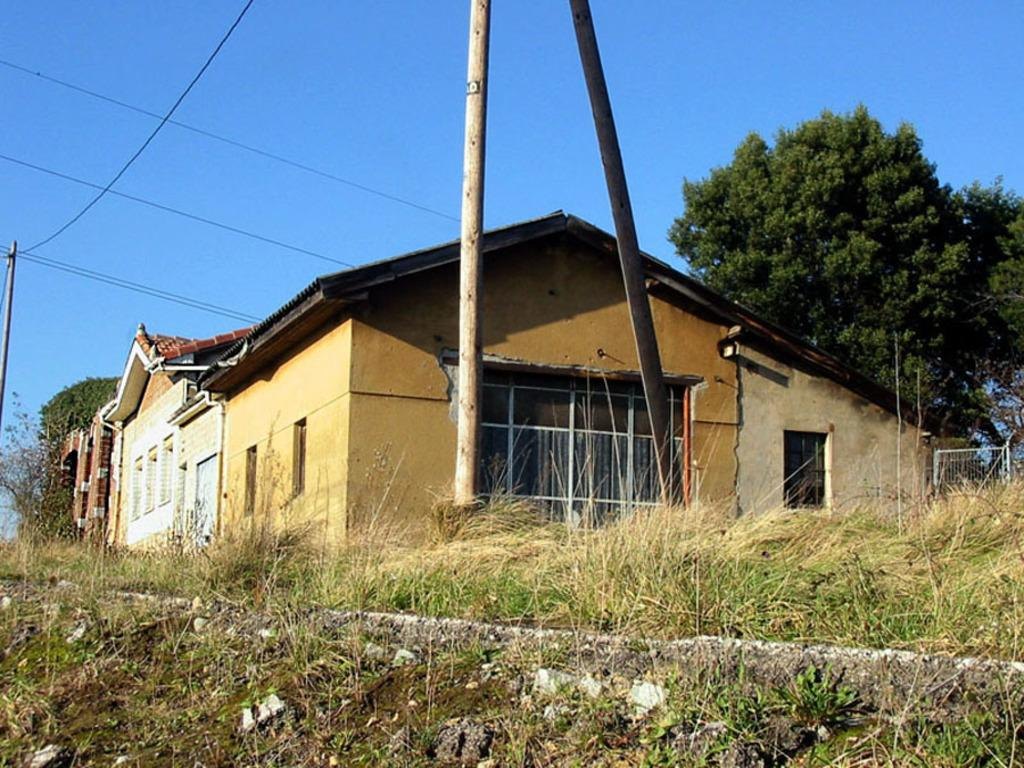What type of vegetation is present in the image? There is grass in the image. What type of structure can be seen in the image? There is a house in the image. What architectural feature is visible on the house? There are windows in the image. What other natural elements are present in the image? There are trees in the image. What part of the natural environment is visible in the image? The sky is visible in the image. Can you tell me how many tigers are walking through the grass in the image? There are no tigers present in the image. Who needs to approve the construction of the house in the image? The image does not provide information about the approval process for the house. 